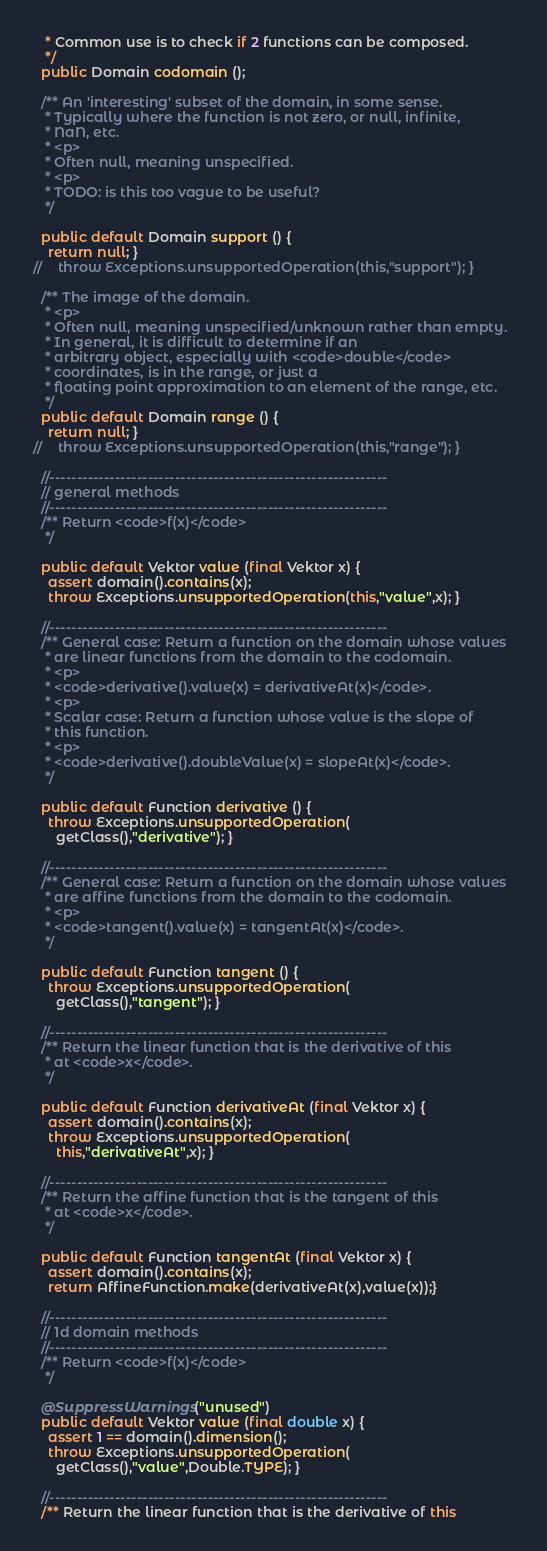<code> <loc_0><loc_0><loc_500><loc_500><_Java_>   * Common use is to check if 2 functions can be composed.
   */
  public Domain codomain ();
  
  /** An 'interesting' subset of the domain, in some sense.
   * Typically where the function is not zero, or null, infinite,
   * NaN, etc. 
   * <p>
   * Often null, meaning unspecified.
   * <p>
   * TODO: is this too vague to be useful?
   */
  
  public default Domain support () {
    return null; }
//    throw Exceptions.unsupportedOperation(this,"support"); }
  
  /** The image of the domain. 
   * <p>
   * Often null, meaning unspecified/unknown rather than empty.
   * In general, it is difficult to determine if an 
   * arbitrary object, especially with <code>double</code> 
   * coordinates, is in the range, or just a
   * floating point approximation to an element of the range, etc.
   */
  public default Domain range () {
    return null; }
//    throw Exceptions.unsupportedOperation(this,"range"); }

  //--------------------------------------------------------------
  // general methods
  //--------------------------------------------------------------
  /** Return <code>f(x)</code>
   */

  public default Vektor value (final Vektor x) {
    assert domain().contains(x);
    throw Exceptions.unsupportedOperation(this,"value",x); }

  //--------------------------------------------------------------
  /** General case: Return a function on the domain whose values  
   * are linear functions from the domain to the codomain.
   * <p>
   * <code>derivative().value(x) = derivativeAt(x)</code>.
   * <p>
   * Scalar case: Return a function whose value is the slope of 
   * this function.
   * <p>
   * <code>derivative().doubleValue(x) = slopeAt(x)</code>.
   */

  public default Function derivative () {
    throw Exceptions.unsupportedOperation(
      getClass(),"derivative"); }

  //--------------------------------------------------------------
  /** General case: Return a function on the domain whose values  
   * are affine functions from the domain to the codomain.
   * <p>
   * <code>tangent().value(x) = tangentAt(x)</code>.
   */

  public default Function tangent () {
    throw Exceptions.unsupportedOperation(
      getClass(),"tangent"); }

  //--------------------------------------------------------------
  /** Return the linear function that is the derivative of this 
   * at <code>x</code>.
   */

  public default Function derivativeAt (final Vektor x) {
    assert domain().contains(x);
    throw Exceptions.unsupportedOperation(
      this,"derivativeAt",x); }

  //--------------------------------------------------------------
  /** Return the affine function that is the tangent of this 
   * at <code>x</code>.
   */

  public default Function tangentAt (final Vektor x) {
    assert domain().contains(x);
    return AffineFunction.make(derivativeAt(x),value(x));}

  //--------------------------------------------------------------
  // 1d domain methods
  //--------------------------------------------------------------
  /** Return <code>f(x)</code>
   */

  @SuppressWarnings("unused")
  public default Vektor value (final double x) {
    assert 1 == domain().dimension();
    throw Exceptions.unsupportedOperation(
      getClass(),"value",Double.TYPE); }

  //--------------------------------------------------------------
  /** Return the linear function that is the derivative of this </code> 